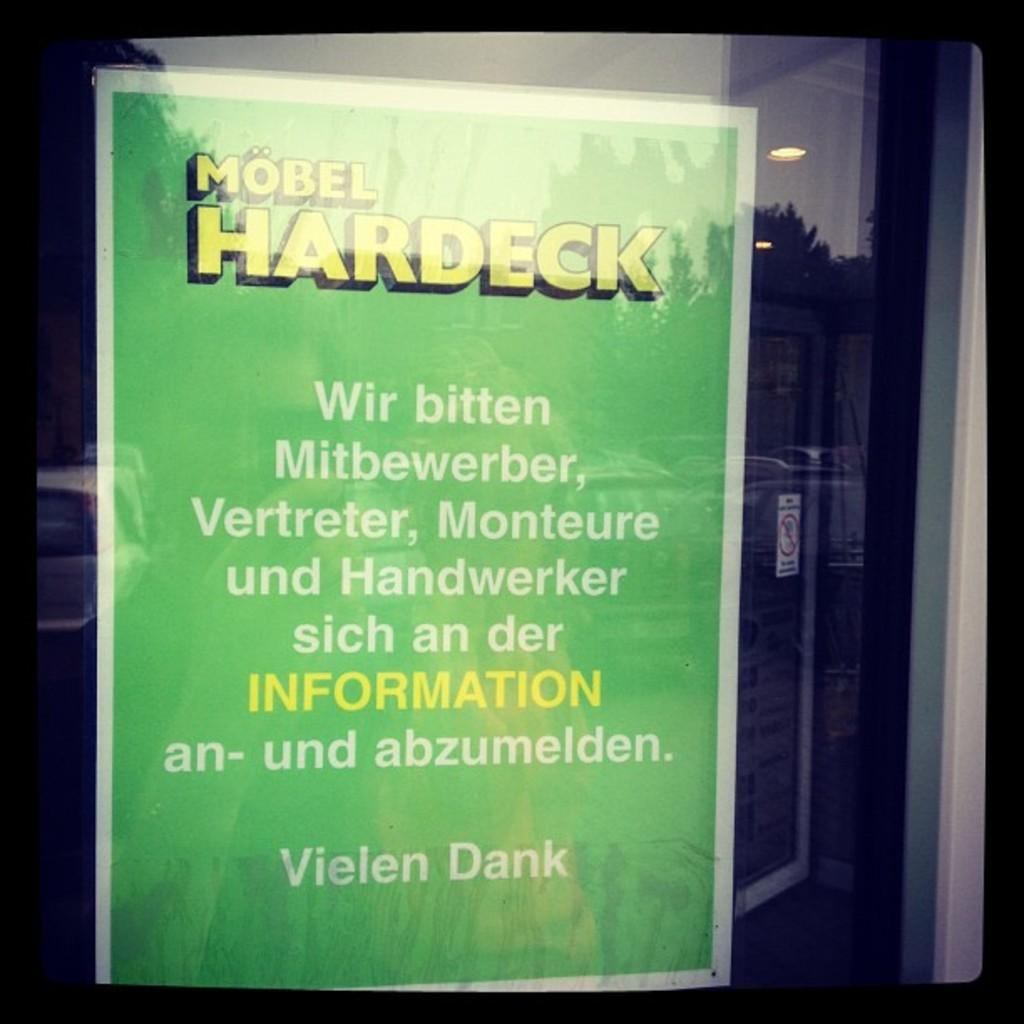<image>
Give a short and clear explanation of the subsequent image. A sign in German hangs in a window for Mobel Hardeck. 